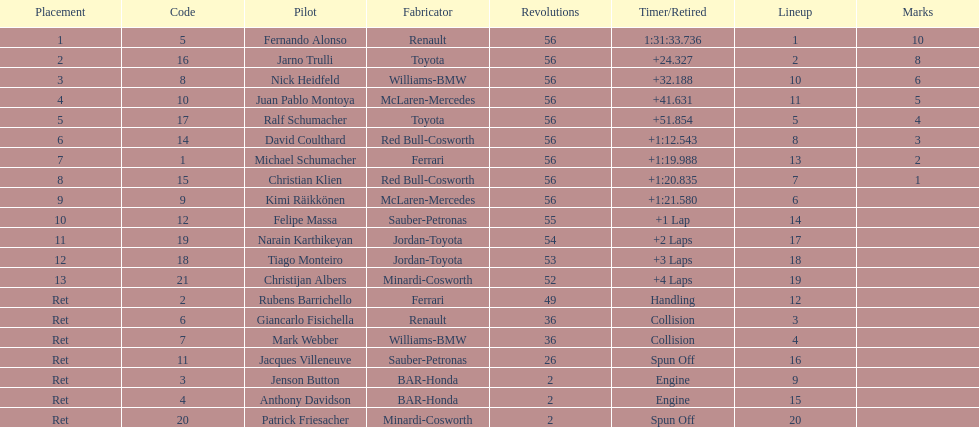Would you mind parsing the complete table? {'header': ['Placement', 'Code', 'Pilot', 'Fabricator', 'Revolutions', 'Timer/Retired', 'Lineup', 'Marks'], 'rows': [['1', '5', 'Fernando Alonso', 'Renault', '56', '1:31:33.736', '1', '10'], ['2', '16', 'Jarno Trulli', 'Toyota', '56', '+24.327', '2', '8'], ['3', '8', 'Nick Heidfeld', 'Williams-BMW', '56', '+32.188', '10', '6'], ['4', '10', 'Juan Pablo Montoya', 'McLaren-Mercedes', '56', '+41.631', '11', '5'], ['5', '17', 'Ralf Schumacher', 'Toyota', '56', '+51.854', '5', '4'], ['6', '14', 'David Coulthard', 'Red Bull-Cosworth', '56', '+1:12.543', '8', '3'], ['7', '1', 'Michael Schumacher', 'Ferrari', '56', '+1:19.988', '13', '2'], ['8', '15', 'Christian Klien', 'Red Bull-Cosworth', '56', '+1:20.835', '7', '1'], ['9', '9', 'Kimi Räikkönen', 'McLaren-Mercedes', '56', '+1:21.580', '6', ''], ['10', '12', 'Felipe Massa', 'Sauber-Petronas', '55', '+1 Lap', '14', ''], ['11', '19', 'Narain Karthikeyan', 'Jordan-Toyota', '54', '+2 Laps', '17', ''], ['12', '18', 'Tiago Monteiro', 'Jordan-Toyota', '53', '+3 Laps', '18', ''], ['13', '21', 'Christijan Albers', 'Minardi-Cosworth', '52', '+4 Laps', '19', ''], ['Ret', '2', 'Rubens Barrichello', 'Ferrari', '49', 'Handling', '12', ''], ['Ret', '6', 'Giancarlo Fisichella', 'Renault', '36', 'Collision', '3', ''], ['Ret', '7', 'Mark Webber', 'Williams-BMW', '36', 'Collision', '4', ''], ['Ret', '11', 'Jacques Villeneuve', 'Sauber-Petronas', '26', 'Spun Off', '16', ''], ['Ret', '3', 'Jenson Button', 'BAR-Honda', '2', 'Engine', '9', ''], ['Ret', '4', 'Anthony Davidson', 'BAR-Honda', '2', 'Engine', '15', ''], ['Ret', '20', 'Patrick Friesacher', 'Minardi-Cosworth', '2', 'Spun Off', '20', '']]} Who finished before nick heidfeld? Jarno Trulli. 